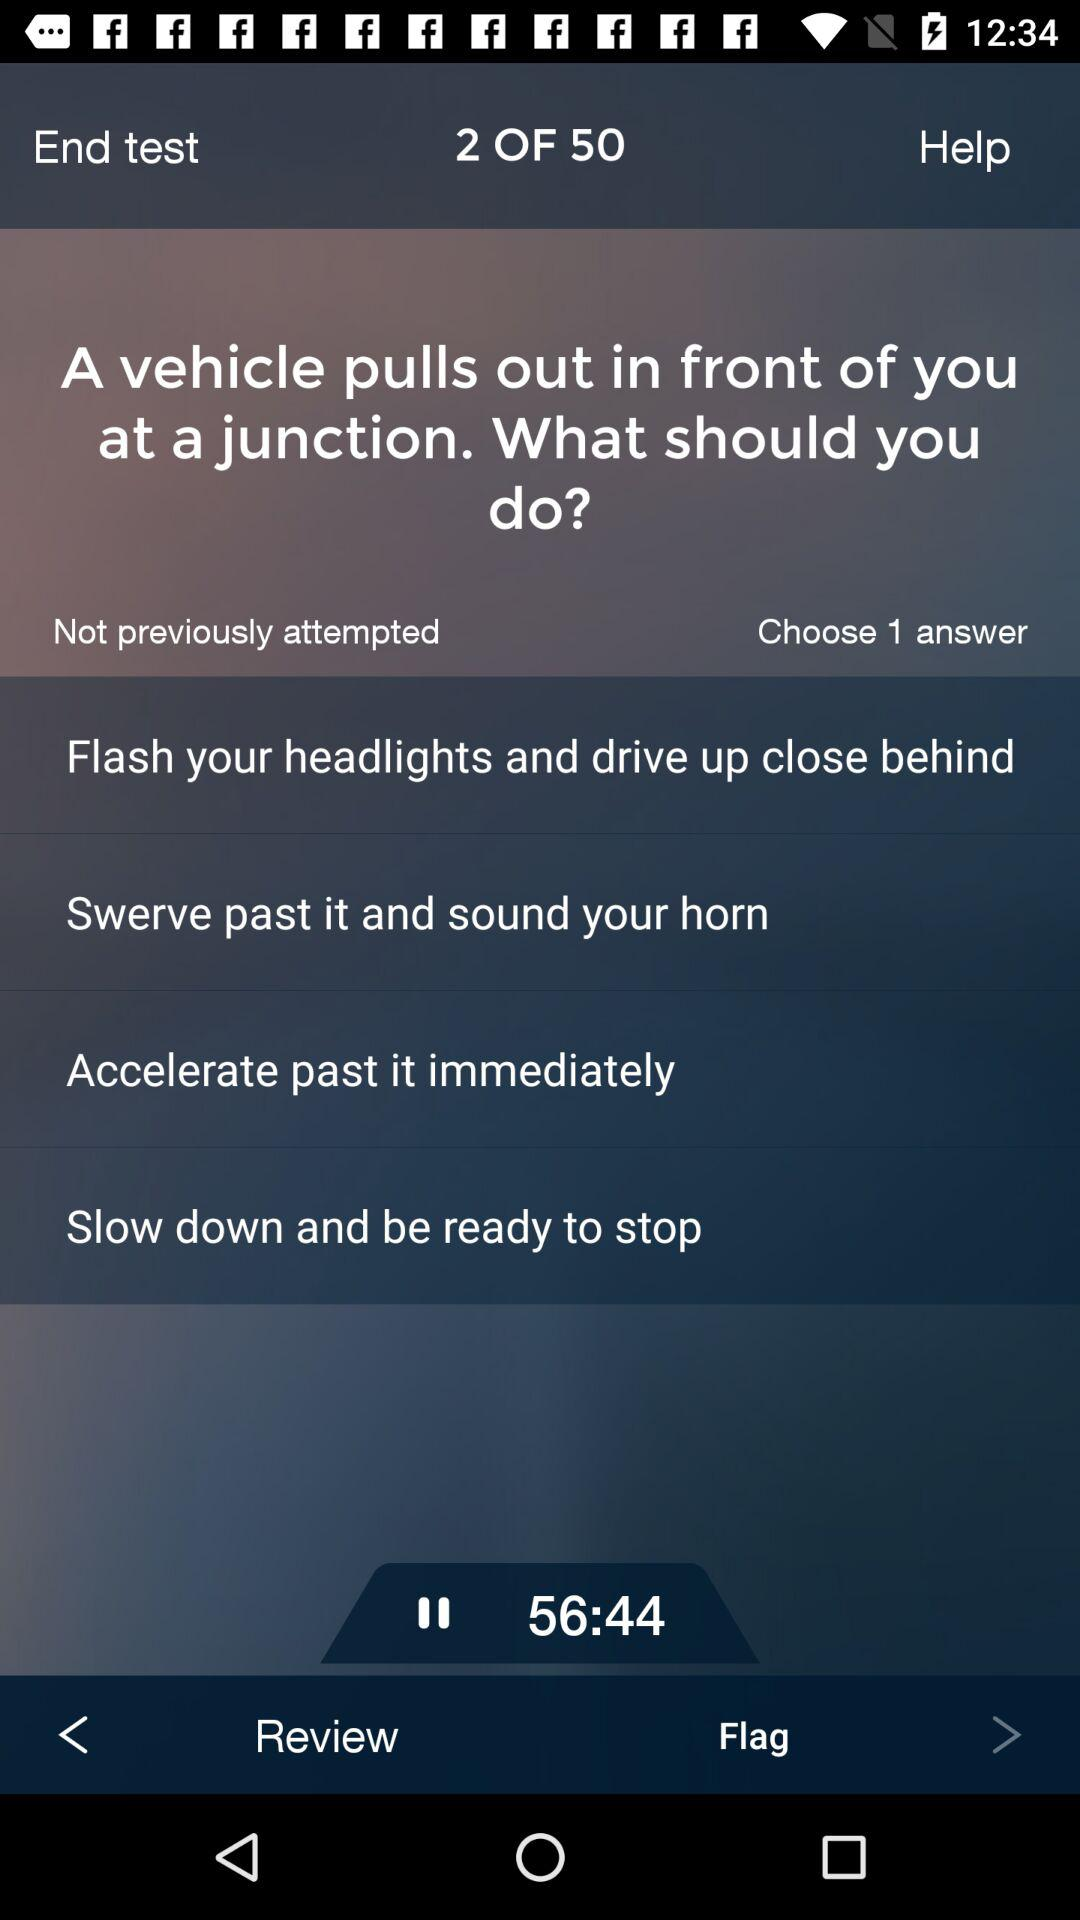At which question am I? You are at the second question. 